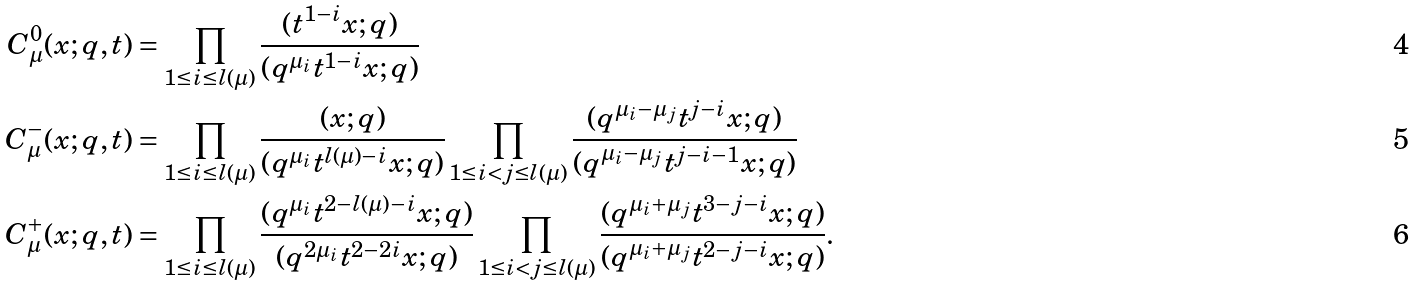Convert formula to latex. <formula><loc_0><loc_0><loc_500><loc_500>C ^ { 0 } _ { \mu } ( x ; q , t ) & = \prod _ { 1 \leq i \leq l ( \mu ) } \frac { ( t ^ { 1 - i } x ; q ) } { ( q ^ { \mu _ { i } } t ^ { 1 - i } x ; q ) } \\ C ^ { - } _ { \mu } ( x ; q , t ) & = \prod _ { 1 \leq i \leq l ( \mu ) } \frac { ( x ; q ) } { ( q ^ { \mu _ { i } } t ^ { l ( \mu ) - i } x ; q ) } \prod _ { 1 \leq i < j \leq l ( \mu ) } \frac { ( q ^ { \mu _ { i } - \mu _ { j } } t ^ { j - i } x ; q ) } { ( q ^ { \mu _ { i } - \mu _ { j } } t ^ { j - i - 1 } x ; q ) } \\ C ^ { + } _ { \mu } ( x ; q , t ) & = \prod _ { 1 \leq i \leq l ( \mu ) } \frac { ( q ^ { \mu _ { i } } t ^ { 2 - l ( \mu ) - i } x ; q ) } { ( q ^ { 2 \mu _ { i } } t ^ { 2 - 2 i } x ; q ) } \prod _ { 1 \leq i < j \leq l ( \mu ) } \frac { ( q ^ { \mu _ { i } + \mu _ { j } } t ^ { 3 - j - i } x ; q ) } { ( q ^ { \mu _ { i } + \mu _ { j } } t ^ { 2 - j - i } x ; q ) } .</formula> 